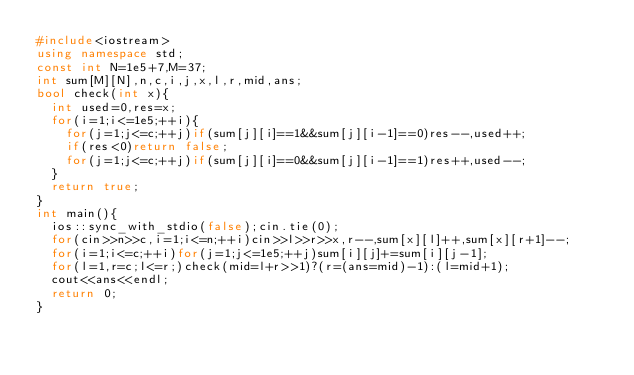Convert code to text. <code><loc_0><loc_0><loc_500><loc_500><_C++_>#include<iostream>
using namespace std;
const int N=1e5+7,M=37;
int sum[M][N],n,c,i,j,x,l,r,mid,ans;
bool check(int x){
	int used=0,res=x;
	for(i=1;i<=1e5;++i){
		for(j=1;j<=c;++j)if(sum[j][i]==1&&sum[j][i-1]==0)res--,used++;
		if(res<0)return false;
		for(j=1;j<=c;++j)if(sum[j][i]==0&&sum[j][i-1]==1)res++,used--;
	}
	return true;
}
int main(){
	ios::sync_with_stdio(false);cin.tie(0);
	for(cin>>n>>c,i=1;i<=n;++i)cin>>l>>r>>x,r--,sum[x][l]++,sum[x][r+1]--;
	for(i=1;i<=c;++i)for(j=1;j<=1e5;++j)sum[i][j]+=sum[i][j-1];
	for(l=1,r=c;l<=r;)check(mid=l+r>>1)?(r=(ans=mid)-1):(l=mid+1);
	cout<<ans<<endl;
	return 0;
} </code> 